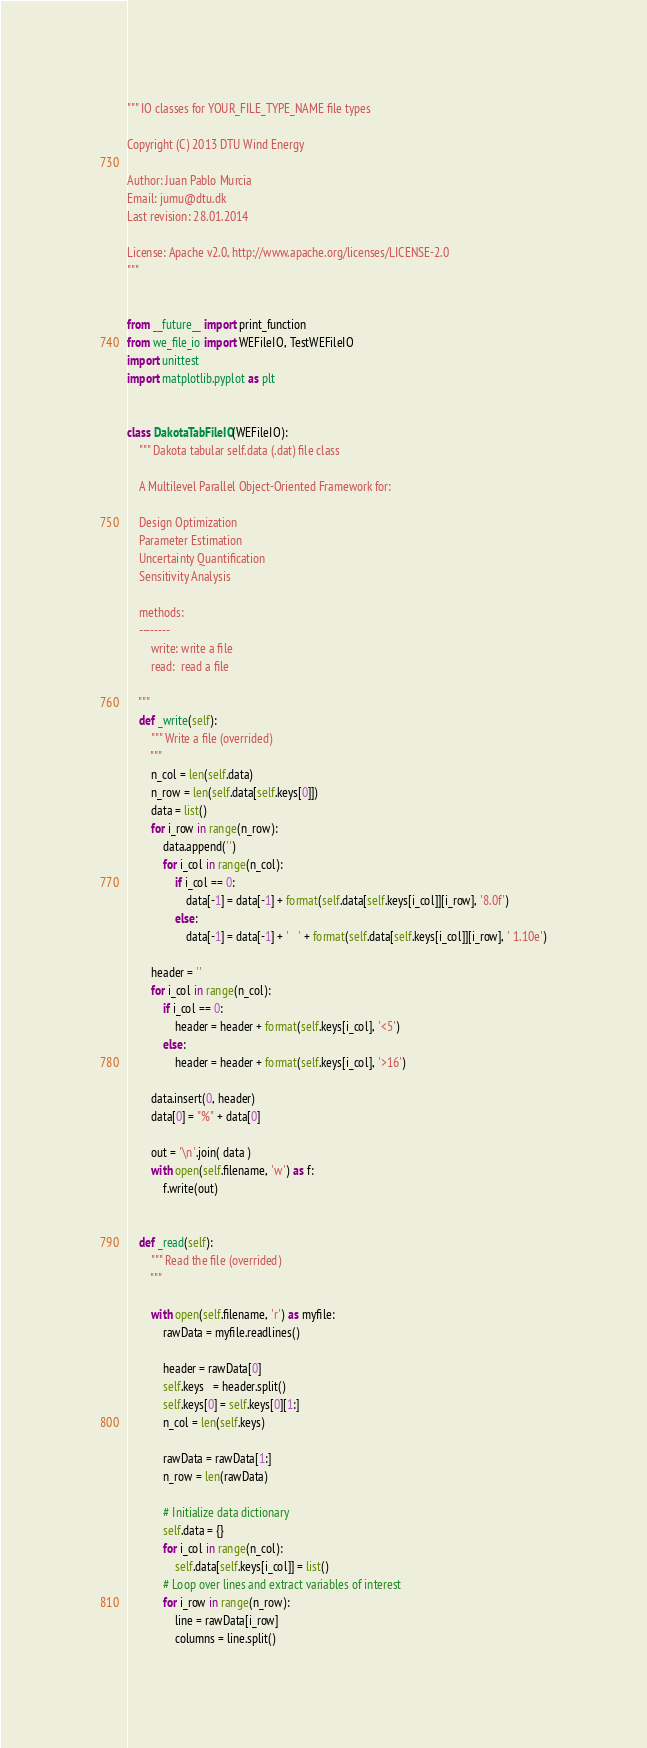Convert code to text. <code><loc_0><loc_0><loc_500><loc_500><_Python_>""" IO classes for YOUR_FILE_TYPE_NAME file types

Copyright (C) 2013 DTU Wind Energy

Author: Juan Pablo Murcia
Email: jumu@dtu.dk
Last revision: 28.01.2014

License: Apache v2.0, http://www.apache.org/licenses/LICENSE-2.0
"""


from __future__ import print_function
from we_file_io import WEFileIO, TestWEFileIO
import unittest
import matplotlib.pyplot as plt


class DakotaTabFileIO(WEFileIO):
    """ Dakota tabular self.data (.dat) file class
    
    A Multilevel Parallel Object-Oriented Framework for:

    Design Optimization
    Parameter Estimation
    Uncertainty Quantification
    Sensitivity Analysis

    methods:
    --------
        write: write a file
        read:  read a file

    """
    def _write(self):
        """ Write a file (overrided)
        """
        n_col = len(self.data)
        n_row = len(self.data[self.keys[0]])
        data = list()
        for i_row in range(n_row):
            data.append('')
            for i_col in range(n_col):
                if i_col == 0:
                    data[-1] = data[-1] + format(self.data[self.keys[i_col]][i_row], '8.0f')
                else:
                    data[-1] = data[-1] + '   ' + format(self.data[self.keys[i_col]][i_row], ' 1.10e')

        header = ''
        for i_col in range(n_col):
            if i_col == 0:
                header = header + format(self.keys[i_col], '<5')
            else:
                header = header + format(self.keys[i_col], '>16')

        data.insert(0, header)
        data[0] = "%" + data[0]

        out = '\n'.join( data )
        with open(self.filename, 'w') as f:
            f.write(out)


    def _read(self):
        """ Read the file (overrided)
        """

        with open(self.filename, 'r') as myfile:
            rawData = myfile.readlines()

            header = rawData[0]
            self.keys   = header.split()
            self.keys[0] = self.keys[0][1:]
            n_col = len(self.keys)

            rawData = rawData[1:]
            n_row = len(rawData)

            # Initialize data dictionary
            self.data = {}
            for i_col in range(n_col):          
                self.data[self.keys[i_col]] = list()
            # Loop over lines and extract variables of interest    
            for i_row in range(n_row):
                line = rawData[i_row]
                columns = line.split()</code> 